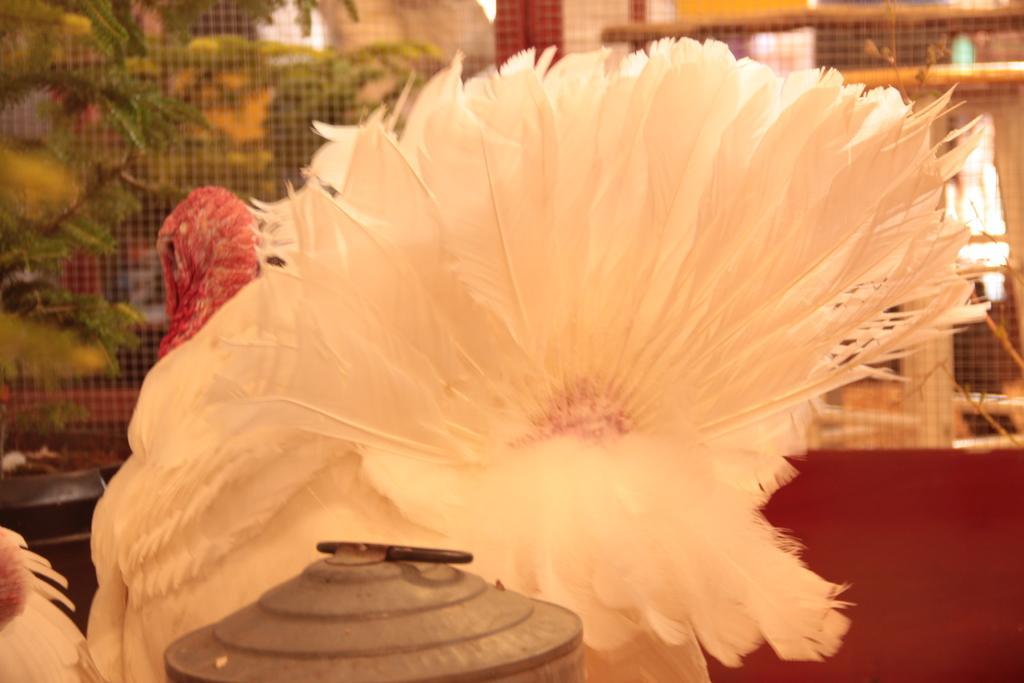How would you summarize this image in a sentence or two? In the center of the image There is a white color bird. At the bottom of the image there is some object. In the background of there is a net and there are some plants. 